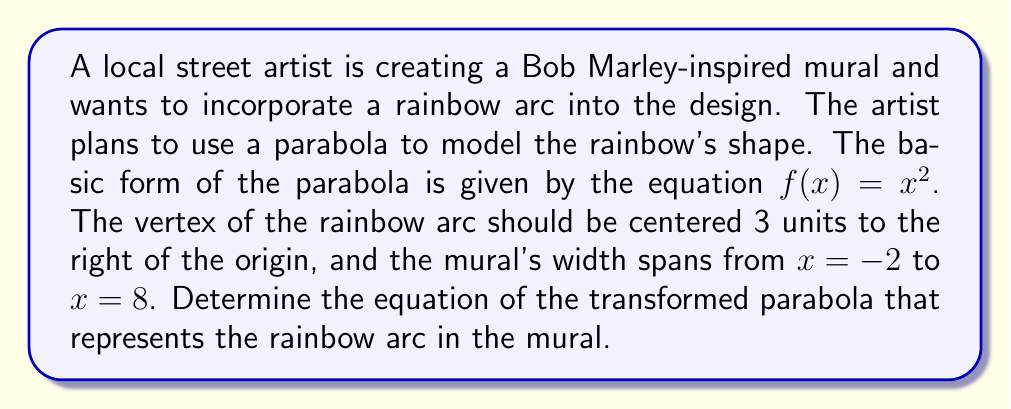Can you solve this math problem? To solve this problem, we need to apply a horizontal shift to the basic parabola equation. Let's break it down step-by-step:

1) The basic form of a parabola is $f(x)=x^2$.

2) To shift a parabola horizontally, we replace $x$ with $(x-h)$, where $h$ is the number of units to shift right (or left if negative).

3) In this case, we need to shift the parabola 3 units to the right, so $h=3$.

4) Substituting $(x-3)$ for $x$ in the original equation:

   $f(x)=(x-3)^2$

5) Expanding this equation:

   $f(x)=x^2-6x+9$

6) This is the equation of the parabola shifted 3 units to the right, which models the rainbow arc in the Bob Marley-inspired mural.

7) We can verify that the vertex is indeed at $x=3$:
   - The axis of symmetry for a parabola in the form $ax^2+bx+c$ is $x=-\frac{b}{2a}$
   - In our case, $a=1$, $b=-6$, so $x=-\frac{-6}{2(1)}=3$

8) The mural's width from $x=-2$ to $x=8$ includes the shifted parabola, ensuring the entire rainbow arc is visible in the mural.
Answer: $f(x)=(x-3)^2$ or $f(x)=x^2-6x+9$ 